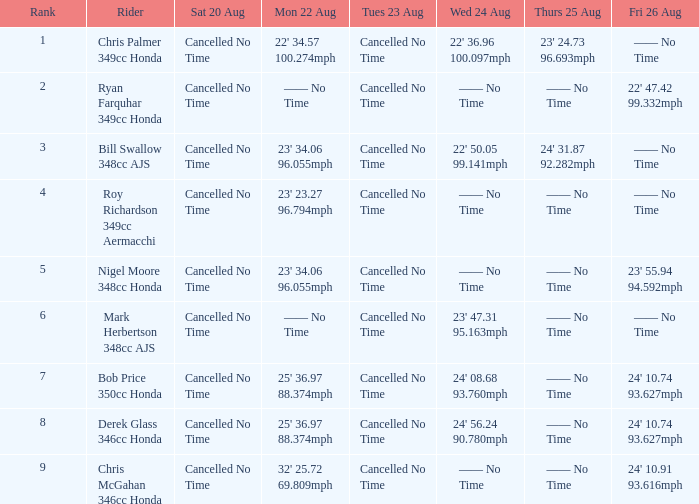What are all the data points for friday, august 26, if the data point for monday, august 22 is 32' 2 24' 10.91 93.616mph. 